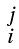<formula> <loc_0><loc_0><loc_500><loc_500>\begin{smallmatrix} j \\ i \end{smallmatrix}</formula> 